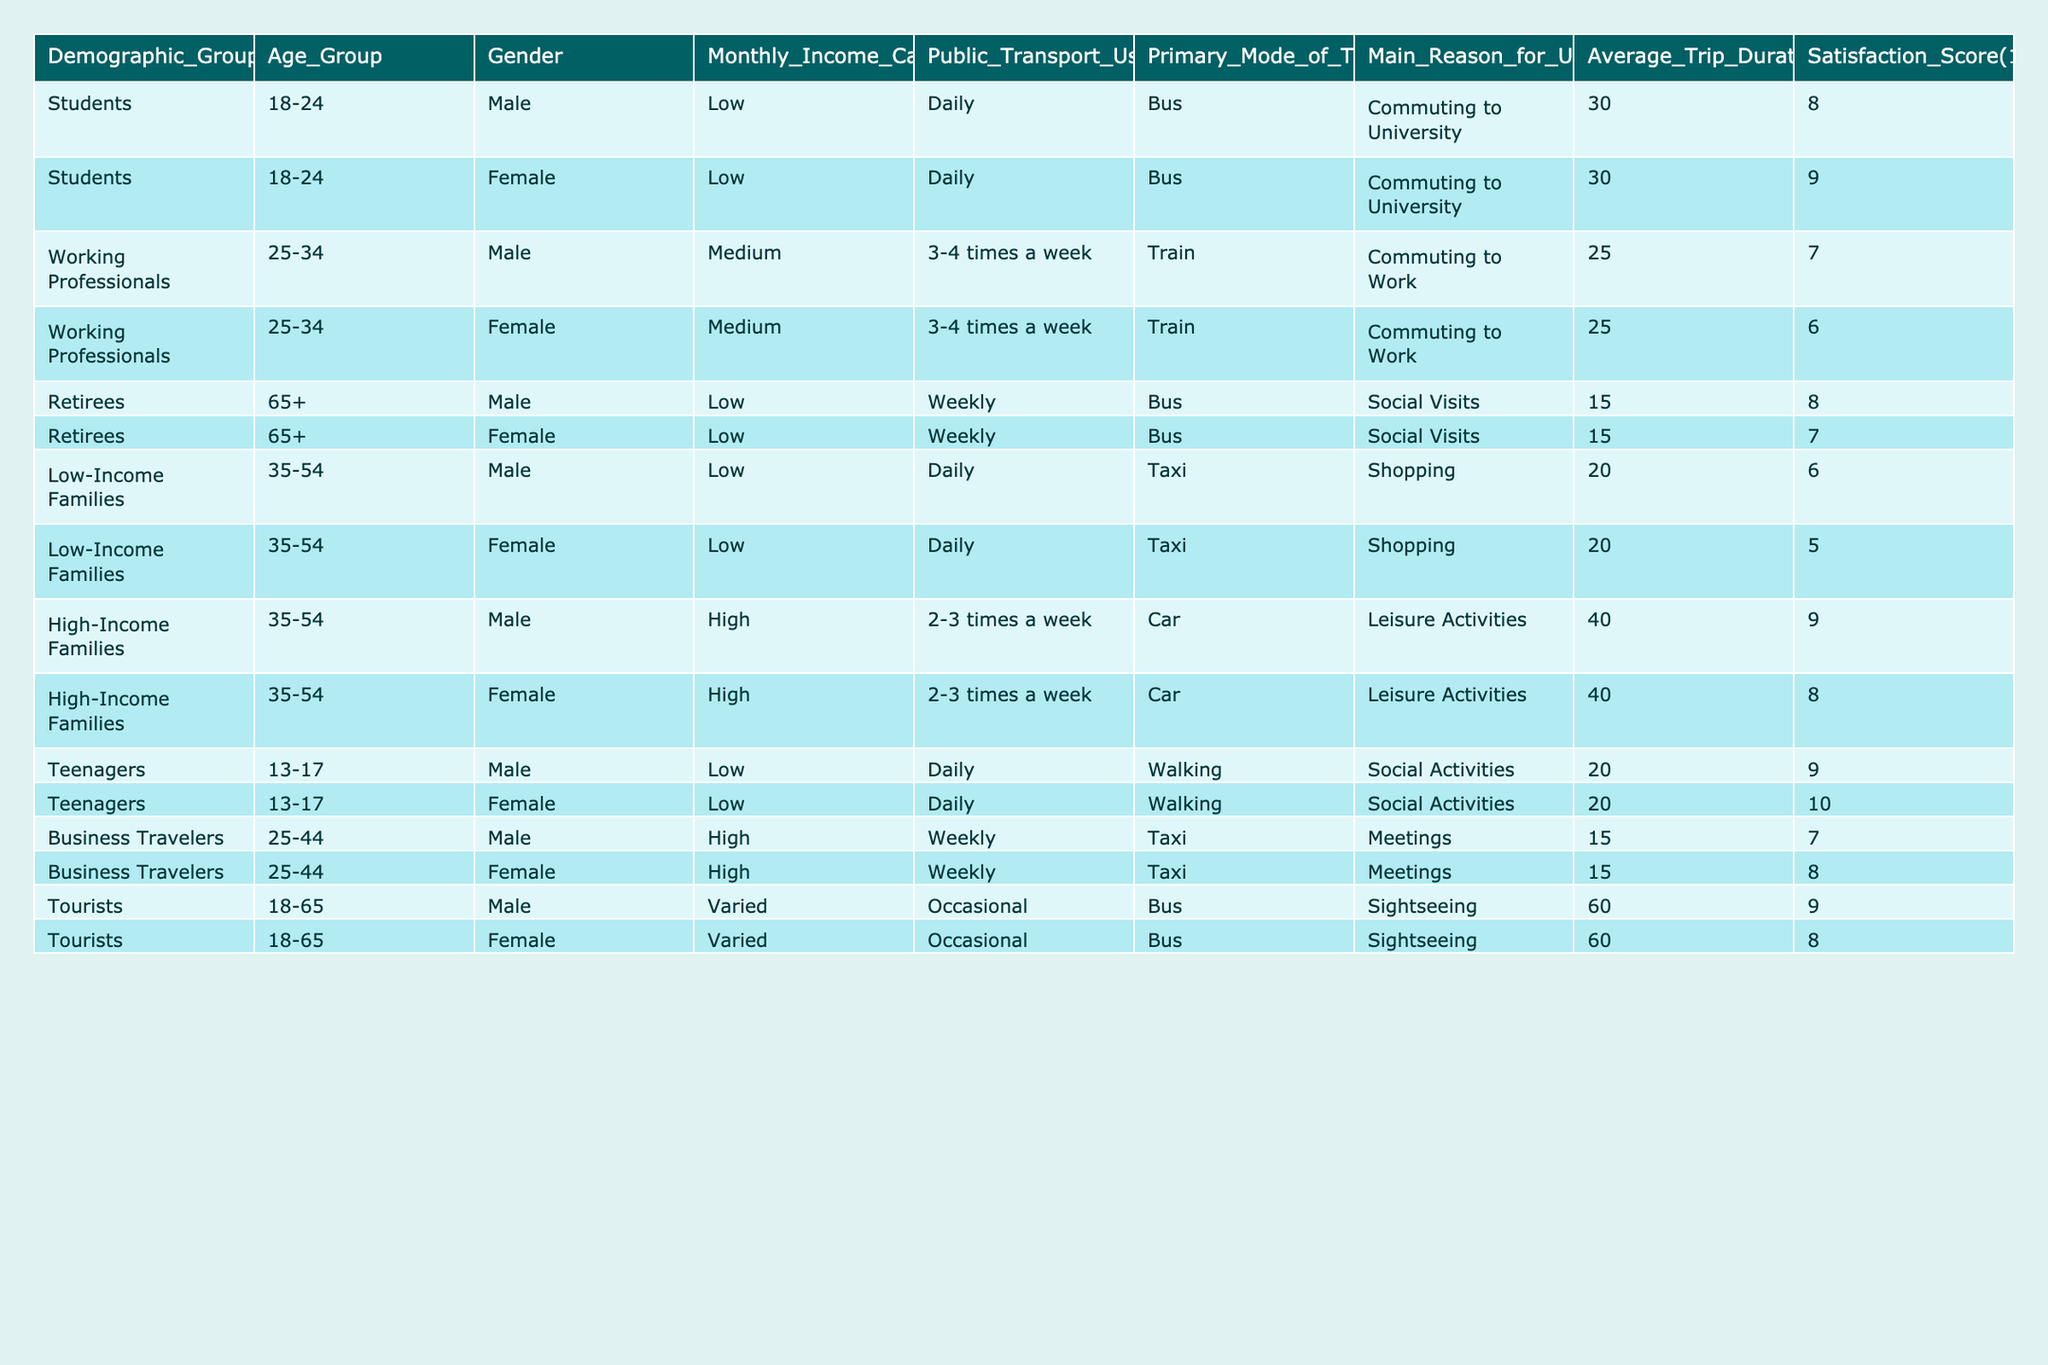What is the primary mode of transport for students? The table lists "Bus" as the primary mode of transport for both male and female students in the age group 18-24.
Answer: Bus What is the average satisfaction score for business travelers? There are two satisfaction scores for business travelers, one for males (7) and one for females (8). The average satisfaction score is (7 + 8) / 2 = 7.5.
Answer: 7.5 Do retirees use public transport more than low-income families? Retirees use public transport weekly, while low-income families use it daily. Thus, low-income families would have a higher usage frequency.
Answer: No What is the total average trip duration for high-income families? Both high-income males and females have an average trip duration of 40 minutes, so the total is (40 + 40) / 2 = 40 minutes.
Answer: 40 minutes What gender has a higher average satisfaction score in the teenage group? The satisfaction score for male teenagers is 9, while for female teenagers, it's 10. Therefore, female teenagers have a higher average satisfaction score.
Answer: Female How many demographic groups use public transport daily? The table shows that students, low-income families, and teenagers use public transport daily. This makes a total of three demographic groups.
Answer: Three Is the main reason for public transport usage the same across different demographics? The main reasons vary; for students, it is commuting to university, for low-income families, it's shopping, and for retirees, it's social visits. Thus, they are not the same.
Answer: No What is the minimum average trip duration across all groups? The minimum average trip duration listed is for retirees, which is 15 minutes.
Answer: 15 minutes Which demographic group has the highest satisfaction score? The highest satisfaction score is 10, which is for female teenagers, making them the demographic group with the highest score.
Answer: Female teenagers Does the table indicate that a majority of high-income families use public transport on a daily basis? The table shows high-income families use public transport 2-3 times a week, not daily. Hence, they are not a majority in daily usage.
Answer: No 